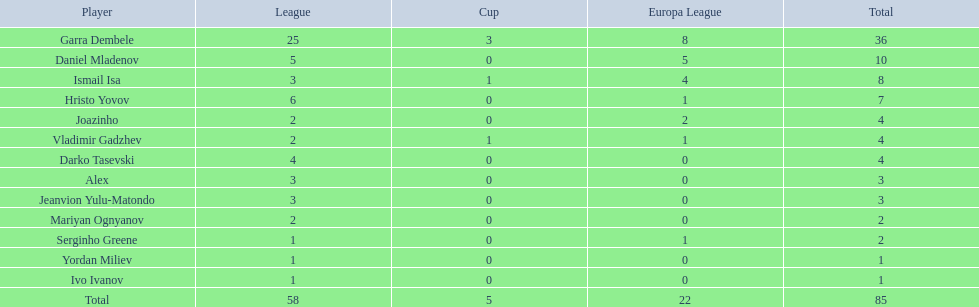What league is 2? 2, 2, 2. Which cup is less than 1? 0, 0. Which total is 2? 2. Who is the player? Mariyan Ognyanov. Can you give me this table in json format? {'header': ['Player', 'League', 'Cup', 'Europa League', 'Total'], 'rows': [['Garra Dembele', '25', '3', '8', '36'], ['Daniel Mladenov', '5', '0', '5', '10'], ['Ismail Isa', '3', '1', '4', '8'], ['Hristo Yovov', '6', '0', '1', '7'], ['Joazinho', '2', '0', '2', '4'], ['Vladimir Gadzhev', '2', '1', '1', '4'], ['Darko Tasevski', '4', '0', '0', '4'], ['Alex', '3', '0', '0', '3'], ['Jeanvion Yulu-Matondo', '3', '0', '0', '3'], ['Mariyan Ognyanov', '2', '0', '0', '2'], ['Serginho Greene', '1', '0', '1', '2'], ['Yordan Miliev', '1', '0', '0', '1'], ['Ivo Ivanov', '1', '0', '0', '1'], ['Total', '58', '5', '22', '85']]} 